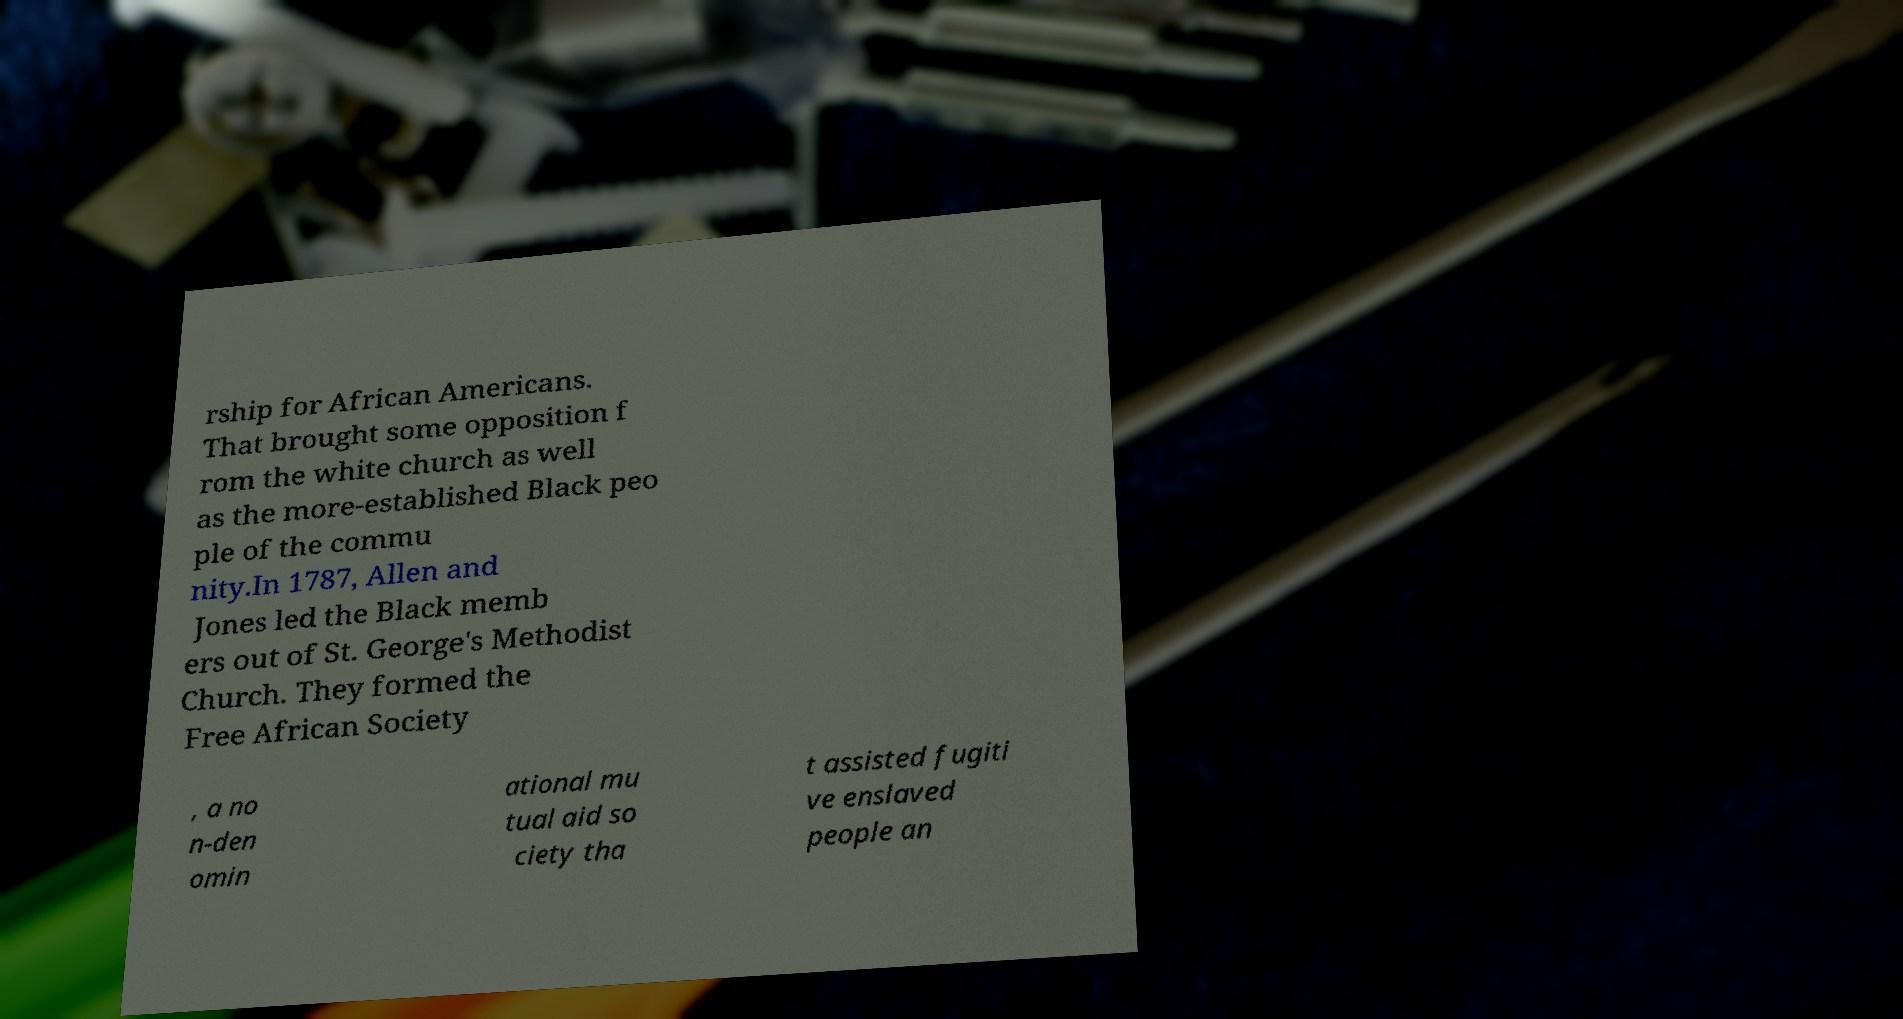For documentation purposes, I need the text within this image transcribed. Could you provide that? rship for African Americans. That brought some opposition f rom the white church as well as the more-established Black peo ple of the commu nity.In 1787, Allen and Jones led the Black memb ers out of St. George's Methodist Church. They formed the Free African Society , a no n-den omin ational mu tual aid so ciety tha t assisted fugiti ve enslaved people an 